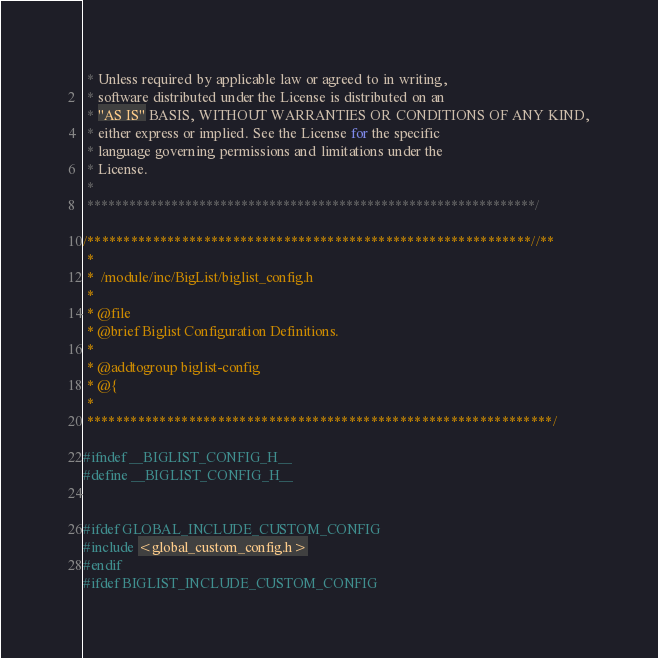Convert code to text. <code><loc_0><loc_0><loc_500><loc_500><_C_> * Unless required by applicable law or agreed to in writing,
 * software distributed under the License is distributed on an
 * "AS IS" BASIS, WITHOUT WARRANTIES OR CONDITIONS OF ANY KIND,
 * either express or implied. See the License for the specific
 * language governing permissions and limitations under the
 * License.
 *
 ****************************************************************/

/*************************************************************//**
 *
 *  /module/inc/BigList/biglist_config.h
 *
 * @file
 * @brief Biglist Configuration Definitions.
 *
 * @addtogroup biglist-config
 * @{
 *
 ****************************************************************/

#ifndef __BIGLIST_CONFIG_H__
#define __BIGLIST_CONFIG_H__


#ifdef GLOBAL_INCLUDE_CUSTOM_CONFIG
#include <global_custom_config.h>
#endif
#ifdef BIGLIST_INCLUDE_CUSTOM_CONFIG</code> 